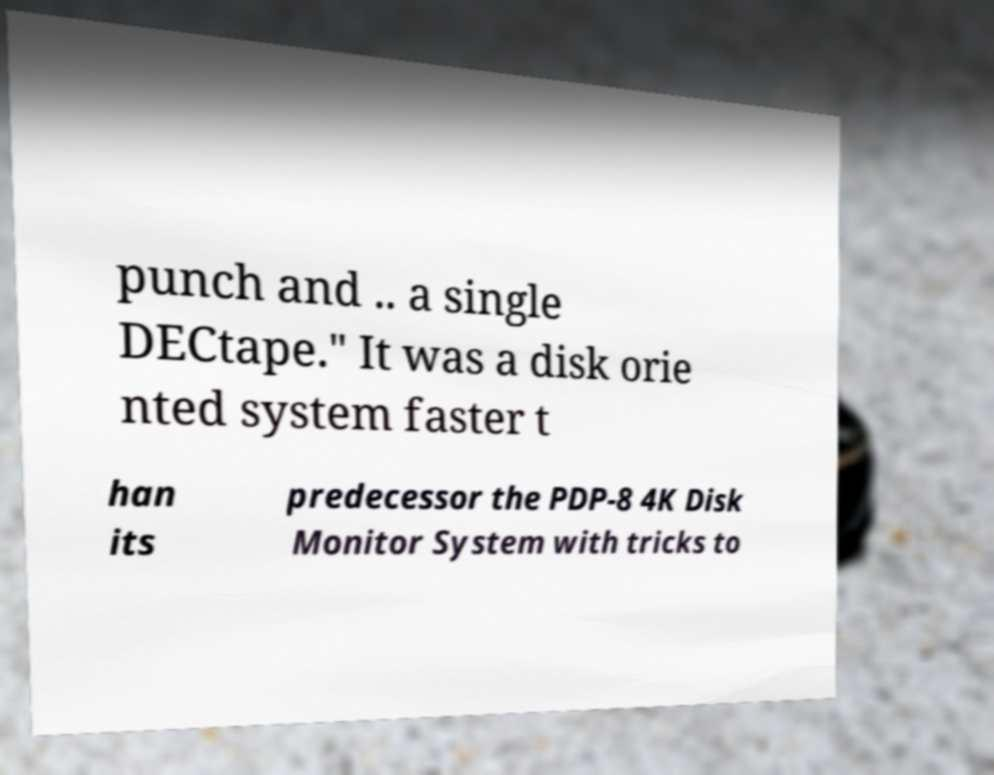Can you read and provide the text displayed in the image?This photo seems to have some interesting text. Can you extract and type it out for me? punch and .. a single DECtape." It was a disk orie nted system faster t han its predecessor the PDP-8 4K Disk Monitor System with tricks to 